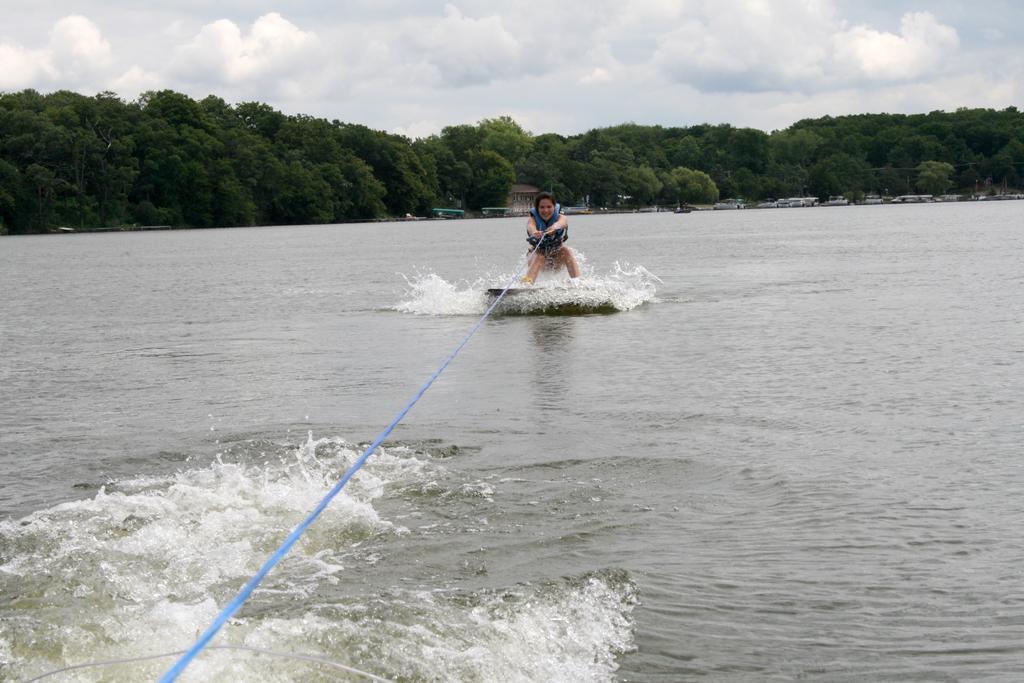Can you describe this image briefly? In this image we can see a person doing water skiing. In the background, we can see the boats and a group of trees. At the top we can see the sky. 